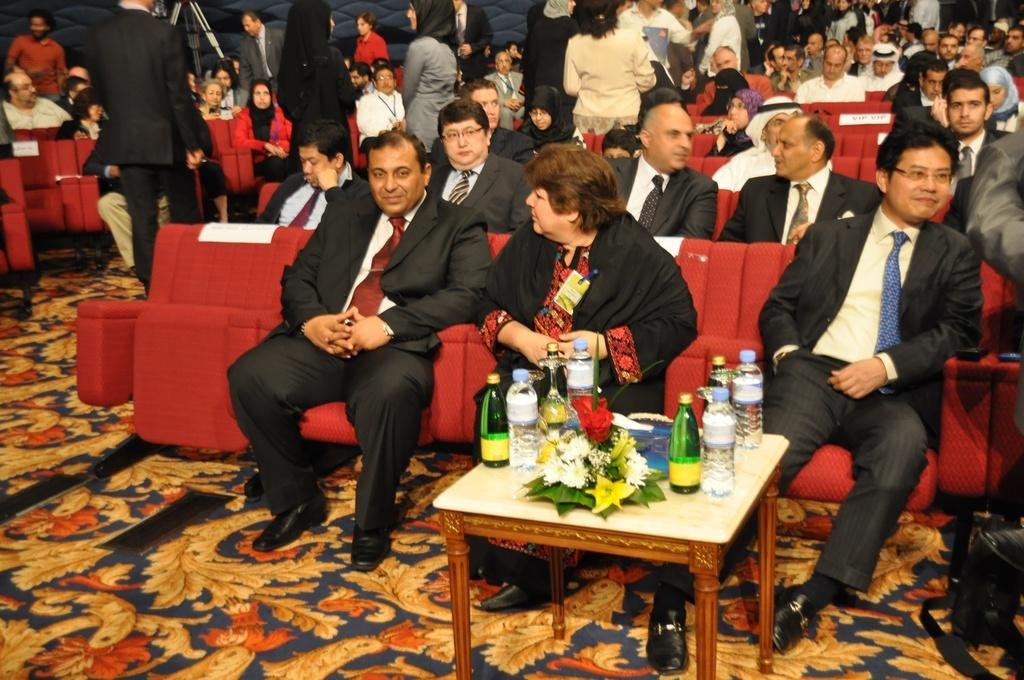What are the people in the image doing? The people in the image are sitting and standing. What is in the middle of the image? There is a table in the middle of the image. What can be seen on the table? There are bottles and a flower bouquet on the table. What type of substance is being consumed by the people in the image? There is no indication of any substance being consumed in the image. What color are the teeth of the people in the image? The image does not show the teeth of the people, so it cannot be determined. 